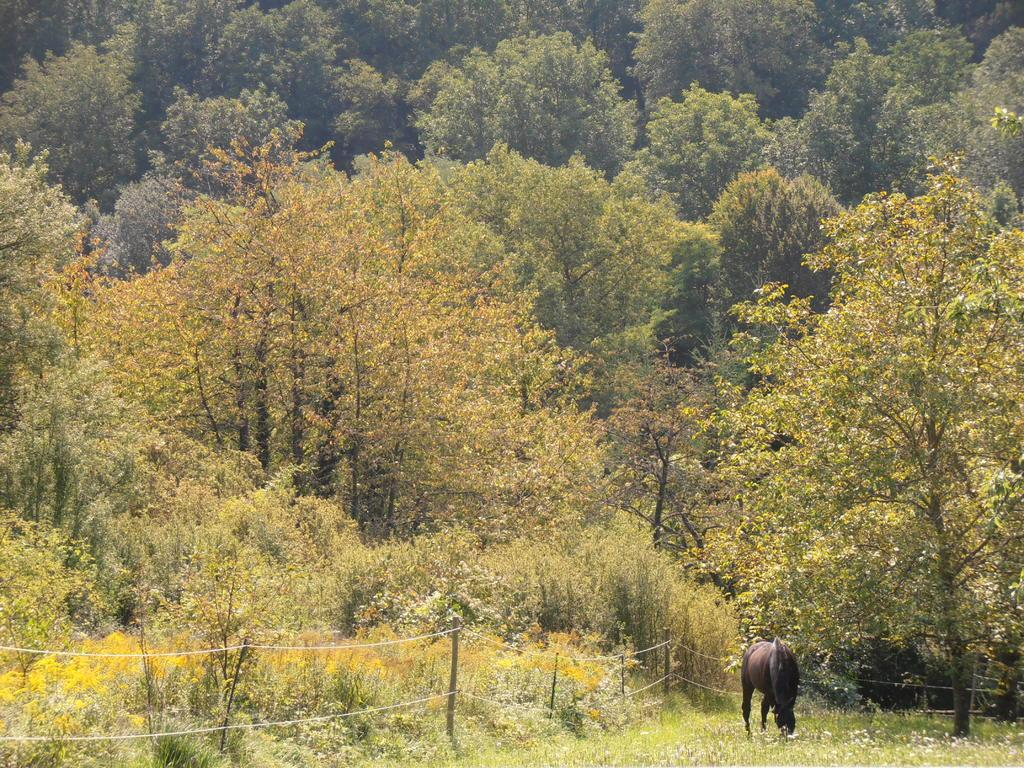What type of terrain is visible at the bottom of the image? There is grass at the bottom of the image. What animal can be seen at the bottom of the image? There is a horse at the bottom of the image. What can be seen in the background of the image? There is fencing and trees in the background of the image. How many cats are sitting on the horse's ear in the image? There are no cats present in the image, and the horse's ear is not visible. 